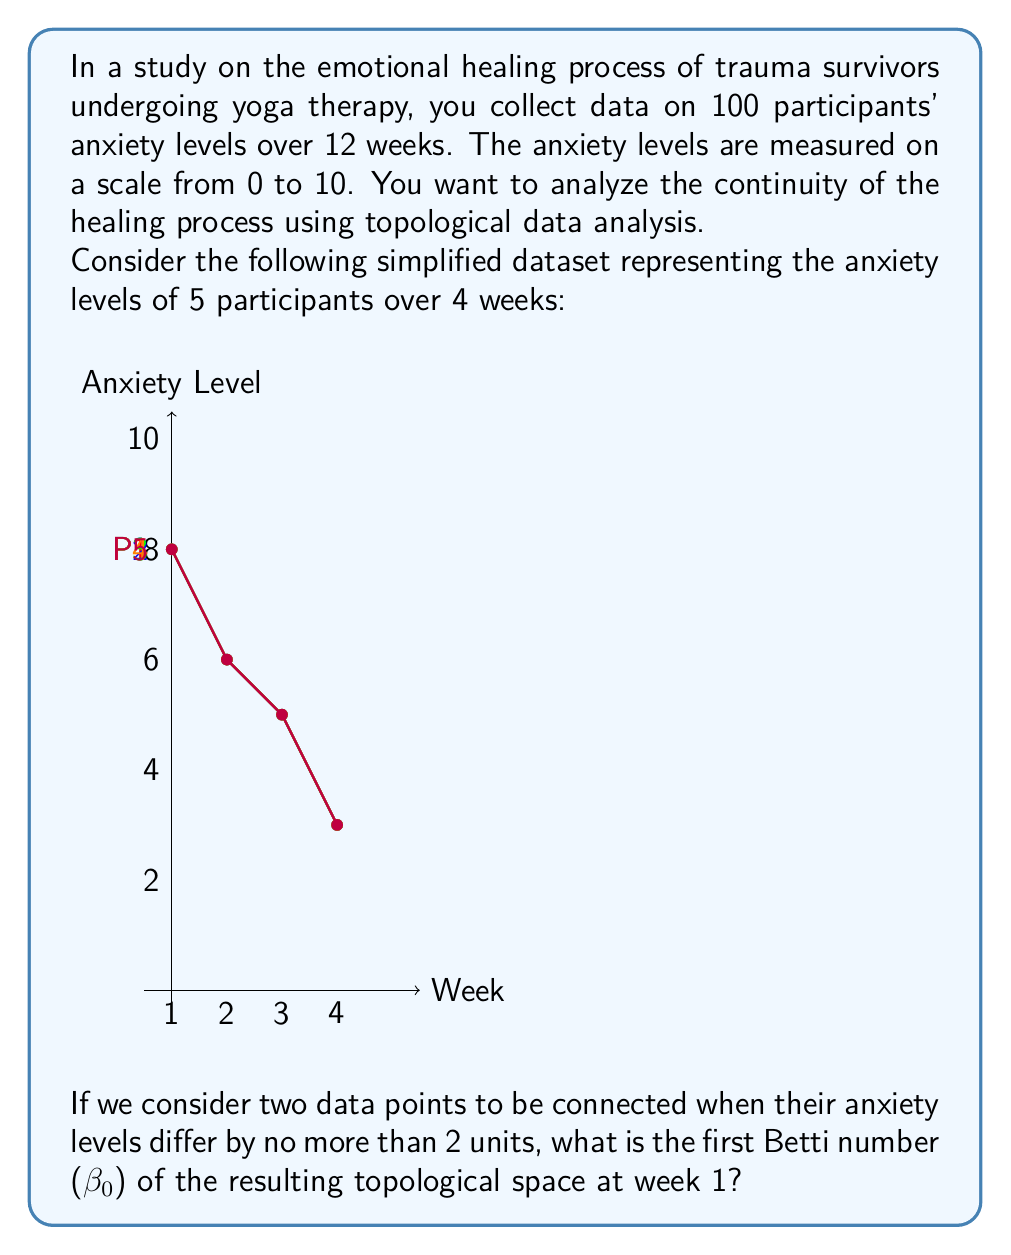Show me your answer to this math problem. To solve this problem, we need to understand the concept of the first Betti number (β₀) in topological data analysis and how it relates to connected components.

Step 1: Understand the first Betti number (β₀)
The first Betti number (β₀) represents the number of connected components in a topological space. In our context, it will tell us how many distinct groups of participants have similar anxiety levels.

Step 2: Determine the connection criterion
Two data points are connected if their anxiety levels differ by no more than 2 units.

Step 3: Analyze the data for week 1
The anxiety levels for week 1 are:
P1: 8
P2: 9
P3: 7
P4: 6
P5: 8

Step 4: Group the connected data points
- P1 (8) and P2 (9) are connected (difference = 1 ≤ 2)
- P1 (8) and P5 (8) are connected (difference = 0 ≤ 2)
- P2 (9) and P5 (8) are connected (difference = 1 ≤ 2)
- P3 (7) and P4 (6) are connected (difference = 1 ≤ 2)
- P3 (7) is not connected to P1, P2, or P5 (differences > 2)
- P4 (6) is not connected to P1, P2, or P5 (differences > 2)

Step 5: Count the number of connected components
We have two distinct groups:
1. P1, P2, and P5
2. P3 and P4

Therefore, the first Betti number (β₀) is 2.

This result indicates that there are two distinct clusters of anxiety levels among the participants at week 1, which could suggest different subgroups in terms of their initial emotional states or responses to trauma.
Answer: $\beta_0 = 2$ 